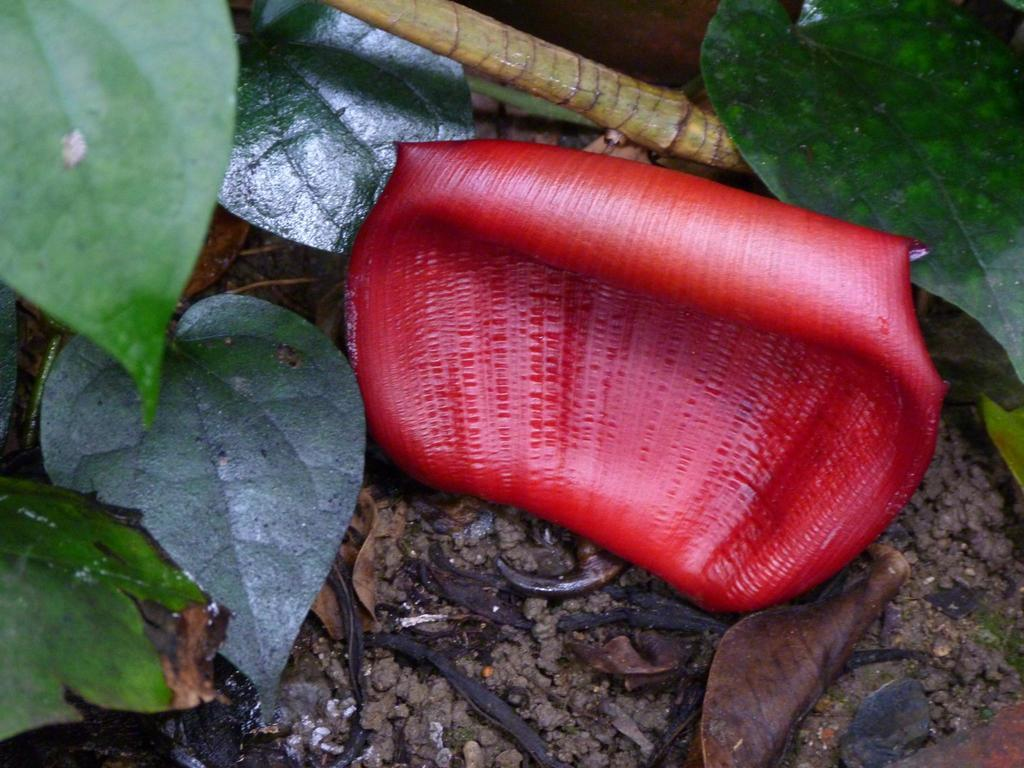What type of plant material can be seen in the image? There are leaves and a petal of a flower in the image. What else is present on the ground in the image? There is a stick on the ground in the image. What type of headwear is visible in the image? There is no headwear present in the image; it only features leaves, a flower petal, and a stick. 